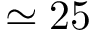Convert formula to latex. <formula><loc_0><loc_0><loc_500><loc_500>\simeq 2 5</formula> 